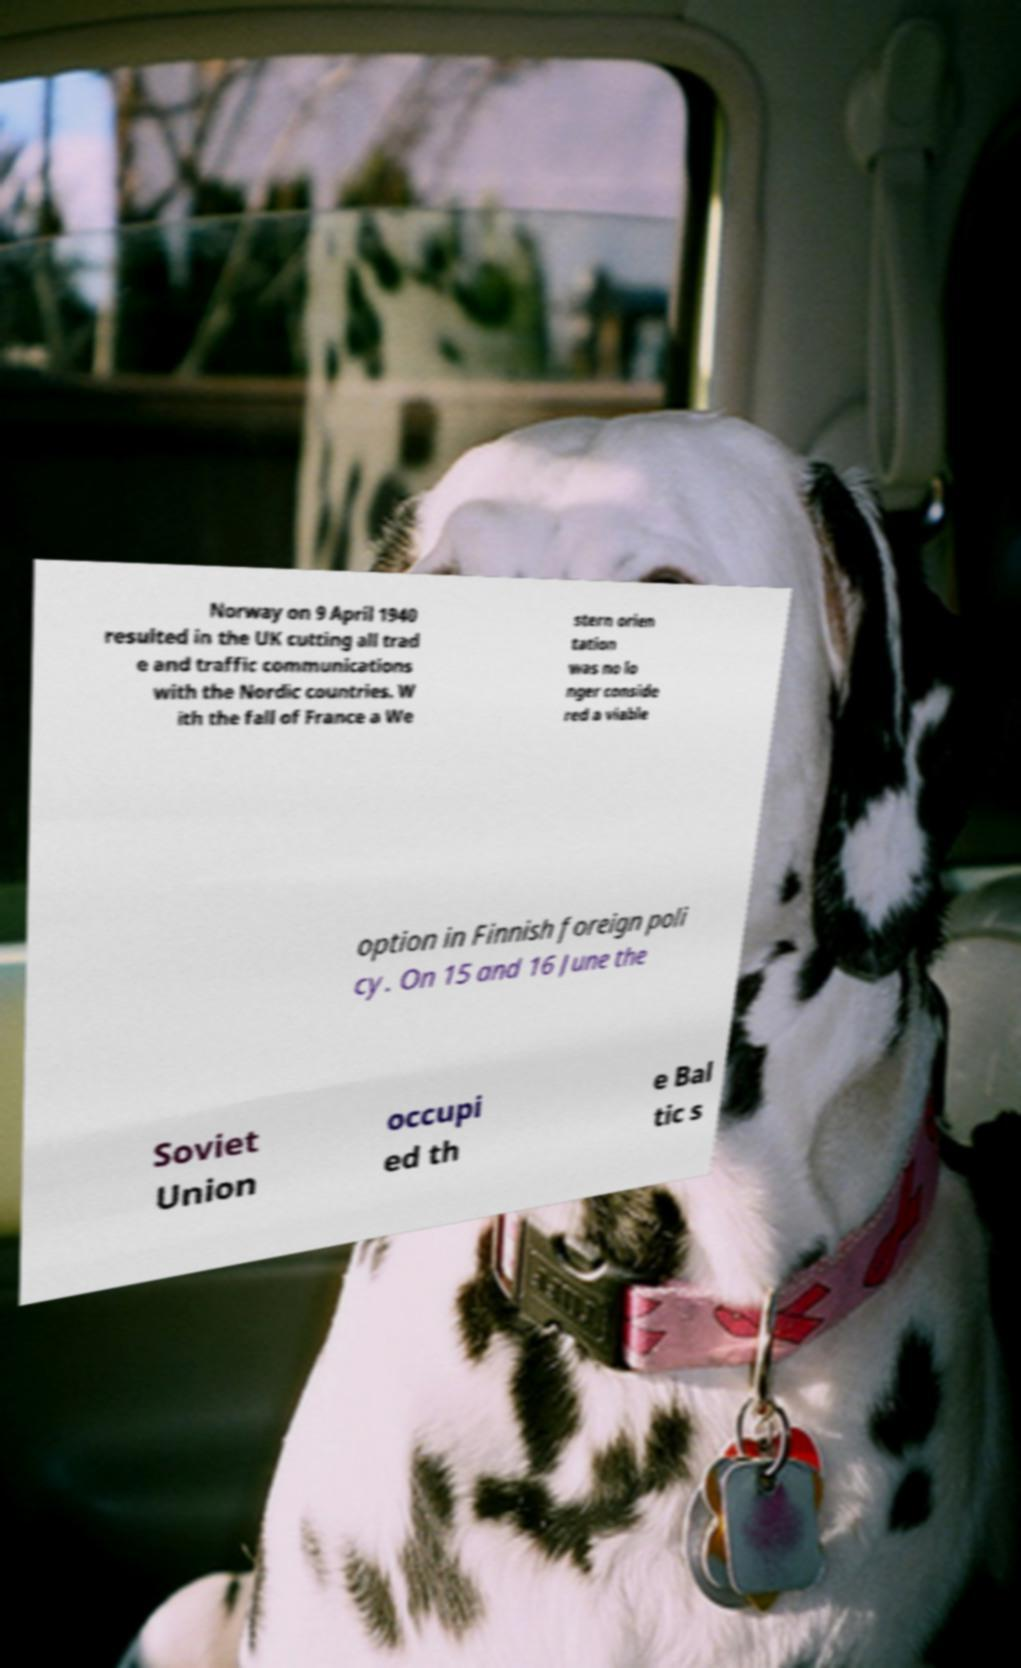Can you accurately transcribe the text from the provided image for me? Norway on 9 April 1940 resulted in the UK cutting all trad e and traffic communications with the Nordic countries. W ith the fall of France a We stern orien tation was no lo nger conside red a viable option in Finnish foreign poli cy. On 15 and 16 June the Soviet Union occupi ed th e Bal tic s 